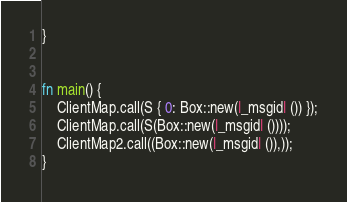Convert code to text. <code><loc_0><loc_0><loc_500><loc_500><_Rust_>}


fn main() {
    ClientMap.call(S { 0: Box::new(|_msgid| ()) });
    ClientMap.call(S(Box::new(|_msgid| ())));
    ClientMap2.call((Box::new(|_msgid| ()),));
}
</code> 